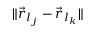Convert formula to latex. <formula><loc_0><loc_0><loc_500><loc_500>\| \vec { r } _ { l _ { j } } - \vec { r } _ { l _ { k } } \|</formula> 